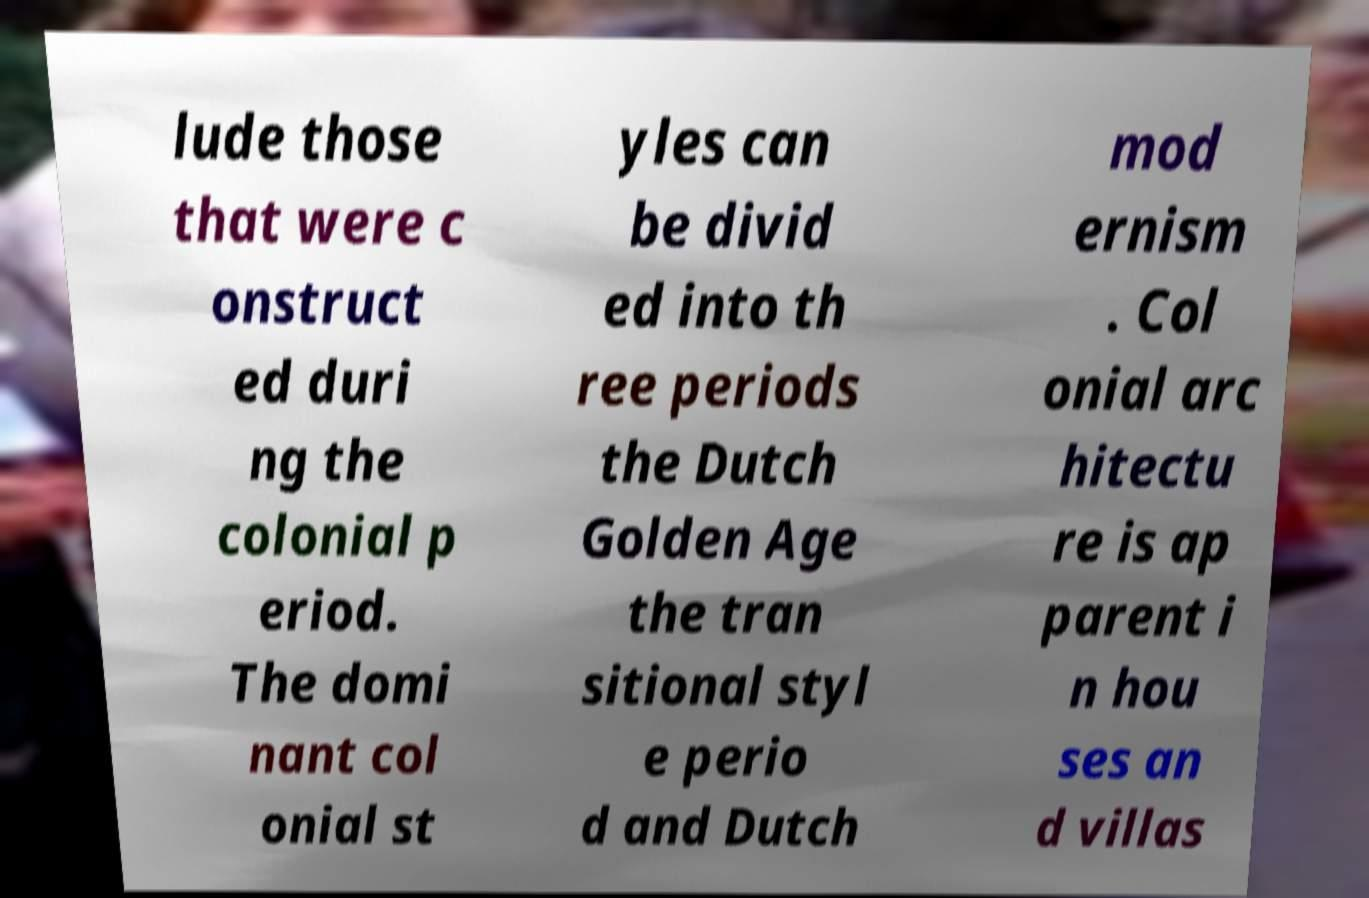Can you accurately transcribe the text from the provided image for me? lude those that were c onstruct ed duri ng the colonial p eriod. The domi nant col onial st yles can be divid ed into th ree periods the Dutch Golden Age the tran sitional styl e perio d and Dutch mod ernism . Col onial arc hitectu re is ap parent i n hou ses an d villas 